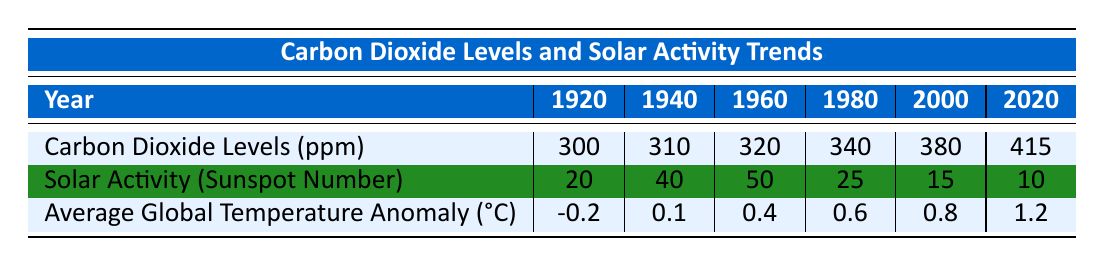What was the carbon dioxide level in 1960? Referring to the row for carbon dioxide levels, in the year 1960, the value is 320 ppm.
Answer: 320 ppm What was the highest solar activity recorded in this dataset? The row for solar activity indicates the values for each year, and the maximum value is 50, which occurred in 1960.
Answer: 50 Is the average global temperature anomaly higher in 2020 than in 2000? The average global temperature anomaly for 2000 is 0.8°C and for 2020 is 1.2°C. Comparing these values shows that 1.2°C is indeed higher than 0.8°C.
Answer: Yes What is the difference in carbon dioxide levels between 1980 and 2000? The carbon dioxide level for 1980 is 340 ppm and for 2000 is 380 ppm. Subtracting these gives 380 - 340 = 40 ppm.
Answer: 40 ppm Did solar activity generally increase or decrease throughout the 20th century according to this data? Looking at the solar activity numbers, there is an increase from 20 to 50 between 1920 and 1960, followed by a decrease to 10 by 2020. Thus, generally, it decreased after peaking in 1960.
Answer: Decreased What is the average carbon dioxide level from 1920 to 2020? The values for carbon dioxide levels from 1920 to 2020 are 300, 310, 320, 340, 380, and 415 ppm. The sum of these values is 300 + 310 + 320 + 340 + 380 + 415 = 2065. There are 6 data points, so the average is 2065 / 6 = 344.17 ppm.
Answer: 344.17 ppm Which year recorded the lowest average global temperature anomaly? The average global temperature anomalies for the years are -0.2°C (1920), 0.1°C (1940), 0.4°C (1960), 0.6°C (1980), 0.8°C (2000), and 1.2°C (2020). The lowest value is -0.2°C in 1920.
Answer: 1920 If solar activity increased by 10 in 1940 compared to 1920, what was the solar activity level in 1920? The solar activity level in 1940 is 40. If it increased by 10, then the 1920 level would be 40 - 10 = 30. Thus, for the year 1920, the solar activity was 30.
Answer: 30 What trend do we see in global temperature anomalies from 1920 to 2020? Observing the average global temperature anomalies: -0.2°C (1920), 0.1°C (1940), 0.4°C (1960), 0.6°C (1980), 0.8°C (2000), and 1.2°C (2020), we see a consistent increase over the 100 years.
Answer: Increasing trend Which year saw an increase in both carbon dioxide levels and global temperature anomaly compared to the previous year? By examining the data, the year 2000 saw a carbon dioxide level increase from 380 ppm in 1980 and a global temperature anomaly increase from 0.6°C in 1980 to 0.8°C. Therefore, the year 2000 meets the criteria.
Answer: 2000 